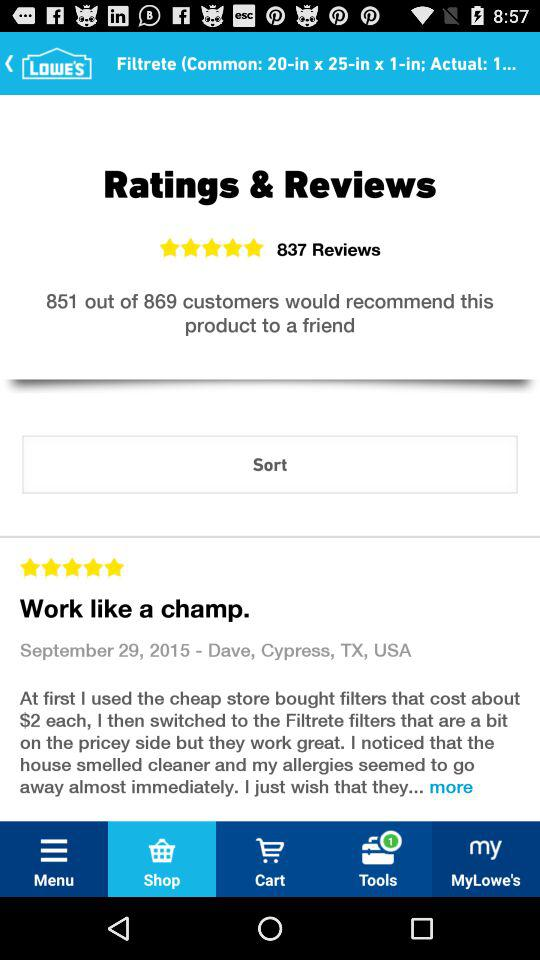Who wrote the review? The review was written by Dave. 